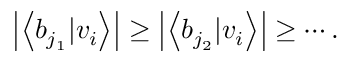<formula> <loc_0><loc_0><loc_500><loc_500>\left | \left \langle b _ { j _ { 1 } } | v _ { i } \right \rangle \right | \geq \left | \left \langle b _ { j _ { 2 } } | v _ { i } \right \rangle \right | \geq \cdots .</formula> 